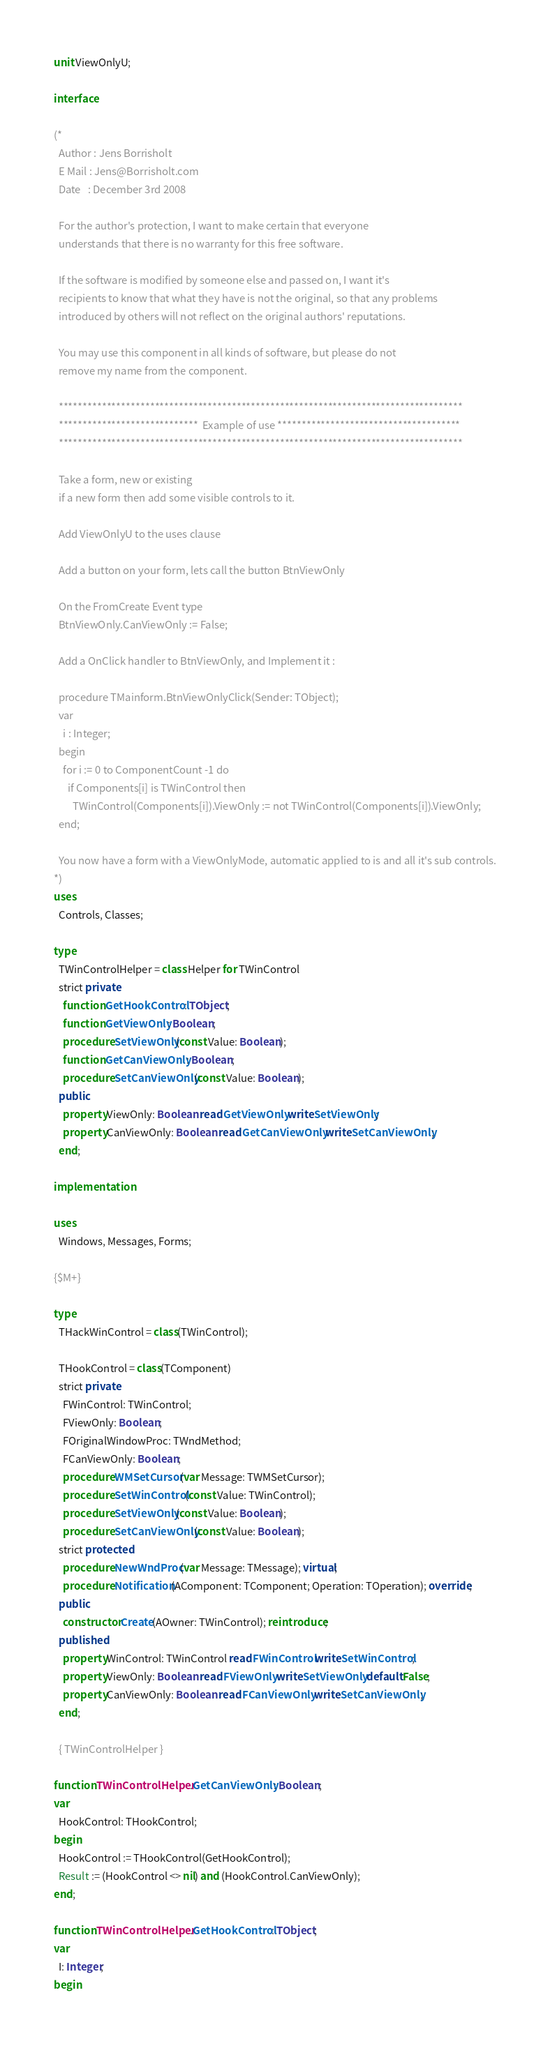Convert code to text. <code><loc_0><loc_0><loc_500><loc_500><_Pascal_>unit ViewOnlyU;

interface

(*
  Author : Jens Borrisholt
  E Mail : Jens@Borrisholt.com
  Date   : December 3rd 2008

  For the author's protection, I want to make certain that everyone
  understands that there is no warranty for this free software.

  If the software is modified by someone else and passed on, I want it's
  recipients to know that what they have is not the original, so that any problems
  introduced by others will not reflect on the original authors' reputations.

  You may use this component in all kinds of software, but please do not
  remove my name from the component.

  ************************************************************************************
  *****************************  Example of use **************************************
  ************************************************************************************

  Take a form, new or existing
  if a new form then add some visible controls to it.

  Add ViewOnlyU to the uses clause

  Add a button on your form, lets call the button BtnViewOnly

  On the FromCreate Event type
  BtnViewOnly.CanViewOnly := False;

  Add a OnClick handler to BtnViewOnly, and Implement it :

  procedure TMainform.BtnViewOnlyClick(Sender: TObject);
  var
    i : Integer;
  begin
    for i := 0 to ComponentCount -1 do
      if Components[i] is TWinControl then
        TWinControl(Components[i]).ViewOnly := not TWinControl(Components[i]).ViewOnly;
  end;

  You now have a form with a ViewOnlyMode, automatic applied to is and all it's sub controls.
*)
uses
  Controls, Classes;

type
  TWinControlHelper = class Helper for TWinControl
  strict private
    function GetHookControl: TObject;
    function GetViewOnly: Boolean;
    procedure SetViewOnly(const Value: Boolean);
    function GetCanViewOnly: Boolean;
    procedure SetCanViewOnly(const Value: Boolean);
  public
    property ViewOnly: Boolean read GetViewOnly write SetViewOnly;
    property CanViewOnly: Boolean read GetCanViewOnly write SetCanViewOnly;
  end;

implementation

uses
  Windows, Messages, Forms;

{$M+}

type
  THackWinControl = class(TWinControl);

  THookControl = class(TComponent)
  strict private
    FWinControl: TWinControl;
    FViewOnly: Boolean;
    FOriginalWindowProc: TWndMethod;
    FCanViewOnly: Boolean;
    procedure WMSetCursor(var Message: TWMSetCursor);
    procedure SetWinControl(const Value: TWinControl);
    procedure SetViewOnly(const Value: Boolean);
    procedure SetCanViewOnly(const Value: Boolean);
  strict protected
    procedure NewWndProc(var Message: TMessage); virtual;
    procedure Notification(AComponent: TComponent; Operation: TOperation); override;
  public
    constructor Create(AOwner: TWinControl); reintroduce;
  published
    property WinControl: TWinControl read FWinControl write SetWinControl;
    property ViewOnly: Boolean read FViewOnly write SetViewOnly default False;
    property CanViewOnly: Boolean read FCanViewOnly write SetCanViewOnly;
  end;

  { TWinControlHelper }

function TWinControlHelper.GetCanViewOnly: Boolean;
var
  HookControl: THookControl;
begin
  HookControl := THookControl(GetHookControl);
  Result := (HookControl <> nil) and (HookControl.CanViewOnly);
end;

function TWinControlHelper.GetHookControl: TObject;
var
  I: Integer;
begin</code> 